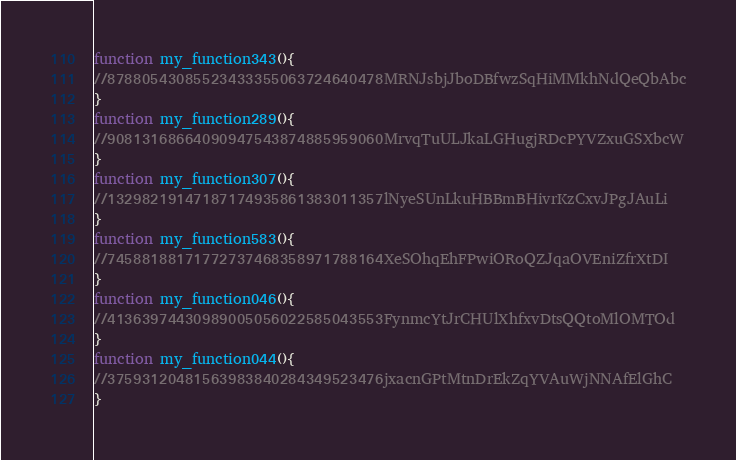<code> <loc_0><loc_0><loc_500><loc_500><_JavaScript_>function my_function343(){ 
//87880543085523433355063724640478MRNJsbjJboDBfwzSqHiMMkhNdQeQbAbc
}
function my_function289(){ 
//90813168664090947543874885959060MrvqTuULJkaLGHugjRDcPYVZxuGSXbcW
}
function my_function307(){ 
//13298219147187174935861383011357lNyeSUnLkuHBBmBHivrKzCxvJPgJAuLi
}
function my_function583(){ 
//74588188171772737468358971788164XeSOhqEhFPwiORoQZJqaOVEniZfrXtDI
}
function my_function046(){ 
//41363974430989005056022585043553FynmcYtJrCHUlXhfxvDtsQQtoMlOMTOd
}
function my_function044(){ 
//37593120481563983840284349523476jxacnGPtMtnDrEkZqYVAuWjNNAfElGhC
}
</code> 